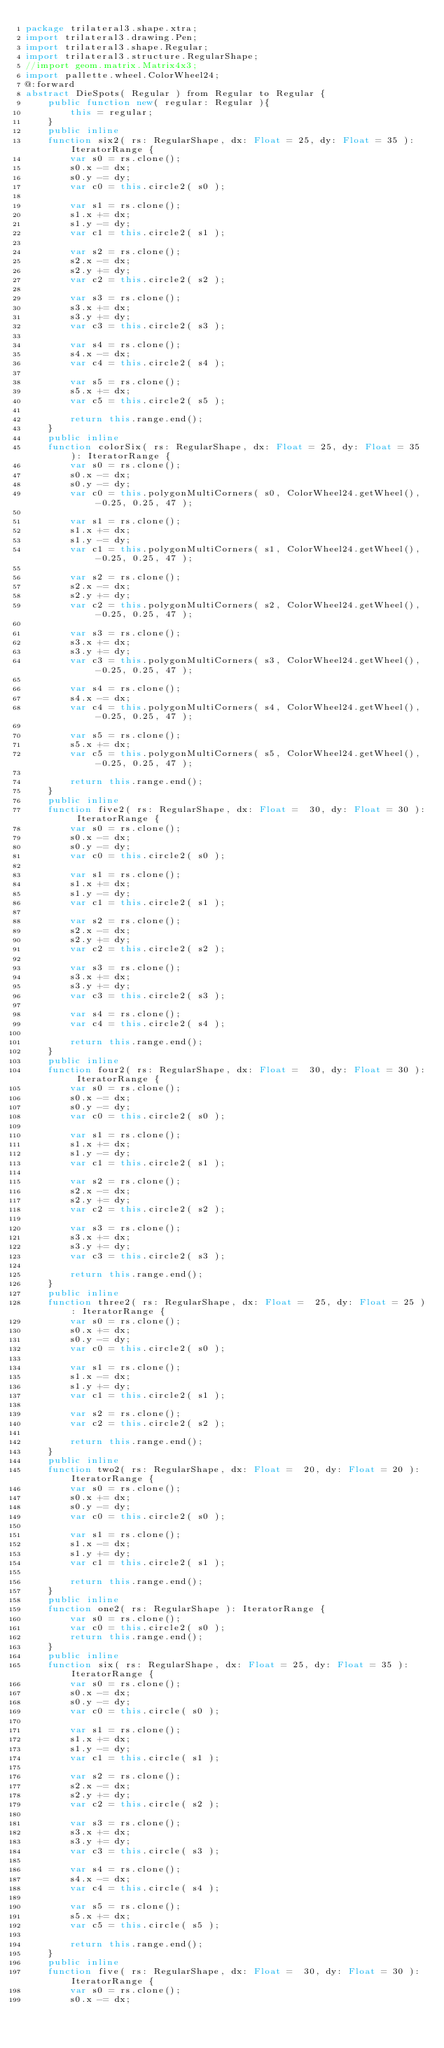<code> <loc_0><loc_0><loc_500><loc_500><_Haxe_>package trilateral3.shape.xtra;
import trilateral3.drawing.Pen;
import trilateral3.shape.Regular;
import trilateral3.structure.RegularShape;
//import geom.matrix.Matrix4x3;
import pallette.wheel.ColorWheel24;
@:forward
abstract DieSpots( Regular ) from Regular to Regular {
    public function new( regular: Regular ){
        this = regular;
    }
    public inline
    function six2( rs: RegularShape, dx: Float = 25, dy: Float = 35 ): IteratorRange {
        var s0 = rs.clone();
        s0.x -= dx;
        s0.y -= dy;
        var c0 = this.circle2( s0 );
        
        var s1 = rs.clone();
        s1.x += dx;
        s1.y -= dy;
        var c1 = this.circle2( s1 );
        
        var s2 = rs.clone();
        s2.x -= dx;
        s2.y += dy;
        var c2 = this.circle2( s2 );
        
        var s3 = rs.clone();
        s3.x += dx;
        s3.y += dy;
        var c3 = this.circle2( s3 );
        
        var s4 = rs.clone();
        s4.x -= dx;
        var c4 = this.circle2( s4 );
        
        var s5 = rs.clone();
        s5.x += dx;
        var c5 = this.circle2( s5 );
        
        return this.range.end();
    }
    public inline
    function colorSix( rs: RegularShape, dx: Float = 25, dy: Float = 35 ): IteratorRange {
        var s0 = rs.clone();
        s0.x -= dx;
        s0.y -= dy;
        var c0 = this.polygonMultiCorners( s0, ColorWheel24.getWheel(), -0.25, 0.25, 47 );
        
        var s1 = rs.clone();
        s1.x += dx;
        s1.y -= dy;
        var c1 = this.polygonMultiCorners( s1, ColorWheel24.getWheel(), -0.25, 0.25, 47 );
        
        var s2 = rs.clone();
        s2.x -= dx;
        s2.y += dy;
        var c2 = this.polygonMultiCorners( s2, ColorWheel24.getWheel(), -0.25, 0.25, 47 );
        
        var s3 = rs.clone();
        s3.x += dx;
        s3.y += dy;
        var c3 = this.polygonMultiCorners( s3, ColorWheel24.getWheel(), -0.25, 0.25, 47 );
        
        var s4 = rs.clone();
        s4.x -= dx;
        var c4 = this.polygonMultiCorners( s4, ColorWheel24.getWheel(), -0.25, 0.25, 47 );
        
        var s5 = rs.clone();
        s5.x += dx;
        var c5 = this.polygonMultiCorners( s5, ColorWheel24.getWheel(), -0.25, 0.25, 47 );
        
        return this.range.end();
    }
    public inline
    function five2( rs: RegularShape, dx: Float =  30, dy: Float = 30 ): IteratorRange {
        var s0 = rs.clone();
        s0.x -= dx;
        s0.y -= dy;
        var c0 = this.circle2( s0 );
        
        var s1 = rs.clone();
        s1.x += dx;
        s1.y -= dy;
        var c1 = this.circle2( s1 );
        
        var s2 = rs.clone();
        s2.x -= dx;
        s2.y += dy;
        var c2 = this.circle2( s2 );
        
        var s3 = rs.clone();
        s3.x += dx;
        s3.y += dy;
        var c3 = this.circle2( s3 );
        
        var s4 = rs.clone();
        var c4 = this.circle2( s4 );
        
        return this.range.end();
    }
    public inline
    function four2( rs: RegularShape, dx: Float =  30, dy: Float = 30 ): IteratorRange {
        var s0 = rs.clone();
        s0.x -= dx;
        s0.y -= dy;
        var c0 = this.circle2( s0 );
        
        var s1 = rs.clone();
        s1.x += dx;
        s1.y -= dy;
        var c1 = this.circle2( s1 );
        
        var s2 = rs.clone();
        s2.x -= dx;
        s2.y += dy;
        var c2 = this.circle2( s2 );
        
        var s3 = rs.clone();
        s3.x += dx;
        s3.y += dy;
        var c3 = this.circle2( s3 );
        
        return this.range.end();
    }
    public inline
    function three2( rs: RegularShape, dx: Float =  25, dy: Float = 25 ): IteratorRange {
        var s0 = rs.clone();
        s0.x += dx;
        s0.y -= dy;
        var c0 = this.circle2( s0 );
        
        var s1 = rs.clone();
        s1.x -= dx;
        s1.y += dy;
        var c1 = this.circle2( s1 );
        
        var s2 = rs.clone();
        var c2 = this.circle2( s2 );
        
        return this.range.end();
    }
    public inline
    function two2( rs: RegularShape, dx: Float =  20, dy: Float = 20 ): IteratorRange {
        var s0 = rs.clone();
        s0.x += dx;
        s0.y -= dy;
        var c0 = this.circle2( s0 );
        
        var s1 = rs.clone();
        s1.x -= dx;
        s1.y += dy;
        var c1 = this.circle2( s1 );
        
        return this.range.end();
    }
    public inline
    function one2( rs: RegularShape ): IteratorRange {
        var s0 = rs.clone();
        var c0 = this.circle2( s0 );
        return this.range.end();
    }
    public inline
    function six( rs: RegularShape, dx: Float = 25, dy: Float = 35 ): IteratorRange {
        var s0 = rs.clone();
        s0.x -= dx;
        s0.y -= dy;
        var c0 = this.circle( s0 );
        
        var s1 = rs.clone();
        s1.x += dx;
        s1.y -= dy;
        var c1 = this.circle( s1 );
        
        var s2 = rs.clone();
        s2.x -= dx;
        s2.y += dy;
        var c2 = this.circle( s2 );
        
        var s3 = rs.clone();
        s3.x += dx;
        s3.y += dy;
        var c3 = this.circle( s3 );
        
        var s4 = rs.clone();
        s4.x -= dx;
        var c4 = this.circle( s4 );
        
        var s5 = rs.clone();
        s5.x += dx;
        var c5 = this.circle( s5 );
        
        return this.range.end();
    }
    public inline
    function five( rs: RegularShape, dx: Float =  30, dy: Float = 30 ): IteratorRange {
        var s0 = rs.clone();
        s0.x -= dx;</code> 